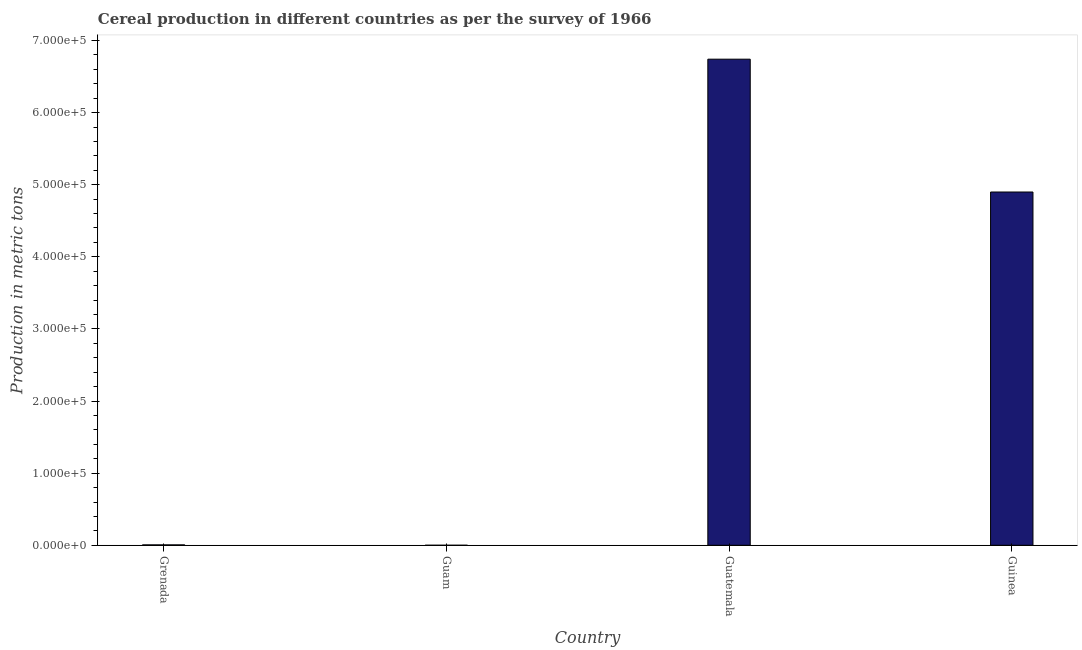Does the graph contain any zero values?
Ensure brevity in your answer.  No. What is the title of the graph?
Your answer should be compact. Cereal production in different countries as per the survey of 1966. What is the label or title of the X-axis?
Ensure brevity in your answer.  Country. What is the label or title of the Y-axis?
Ensure brevity in your answer.  Production in metric tons. What is the cereal production in Guatemala?
Provide a succinct answer. 6.74e+05. Across all countries, what is the maximum cereal production?
Your answer should be very brief. 6.74e+05. Across all countries, what is the minimum cereal production?
Keep it short and to the point. 5. In which country was the cereal production maximum?
Your response must be concise. Guatemala. In which country was the cereal production minimum?
Provide a succinct answer. Guam. What is the sum of the cereal production?
Your answer should be compact. 1.16e+06. What is the difference between the cereal production in Grenada and Guatemala?
Make the answer very short. -6.74e+05. What is the average cereal production per country?
Ensure brevity in your answer.  2.91e+05. What is the median cereal production?
Give a very brief answer. 2.45e+05. In how many countries, is the cereal production greater than 300000 metric tons?
Provide a succinct answer. 2. What is the ratio of the cereal production in Guatemala to that in Guinea?
Ensure brevity in your answer.  1.38. Is the difference between the cereal production in Grenada and Guatemala greater than the difference between any two countries?
Ensure brevity in your answer.  No. What is the difference between the highest and the second highest cereal production?
Offer a very short reply. 1.84e+05. What is the difference between the highest and the lowest cereal production?
Your response must be concise. 6.74e+05. How many bars are there?
Ensure brevity in your answer.  4. Are all the bars in the graph horizontal?
Offer a terse response. No. How many countries are there in the graph?
Provide a succinct answer. 4. What is the difference between two consecutive major ticks on the Y-axis?
Offer a terse response. 1.00e+05. What is the Production in metric tons in Grenada?
Offer a very short reply. 540. What is the Production in metric tons in Guatemala?
Provide a short and direct response. 6.74e+05. What is the Production in metric tons of Guinea?
Give a very brief answer. 4.90e+05. What is the difference between the Production in metric tons in Grenada and Guam?
Keep it short and to the point. 535. What is the difference between the Production in metric tons in Grenada and Guatemala?
Offer a terse response. -6.74e+05. What is the difference between the Production in metric tons in Grenada and Guinea?
Make the answer very short. -4.89e+05. What is the difference between the Production in metric tons in Guam and Guatemala?
Offer a very short reply. -6.74e+05. What is the difference between the Production in metric tons in Guam and Guinea?
Your answer should be very brief. -4.90e+05. What is the difference between the Production in metric tons in Guatemala and Guinea?
Your answer should be very brief. 1.84e+05. What is the ratio of the Production in metric tons in Grenada to that in Guam?
Make the answer very short. 108. What is the ratio of the Production in metric tons in Grenada to that in Guatemala?
Offer a very short reply. 0. What is the ratio of the Production in metric tons in Grenada to that in Guinea?
Provide a short and direct response. 0. What is the ratio of the Production in metric tons in Guam to that in Guatemala?
Offer a terse response. 0. What is the ratio of the Production in metric tons in Guatemala to that in Guinea?
Make the answer very short. 1.38. 